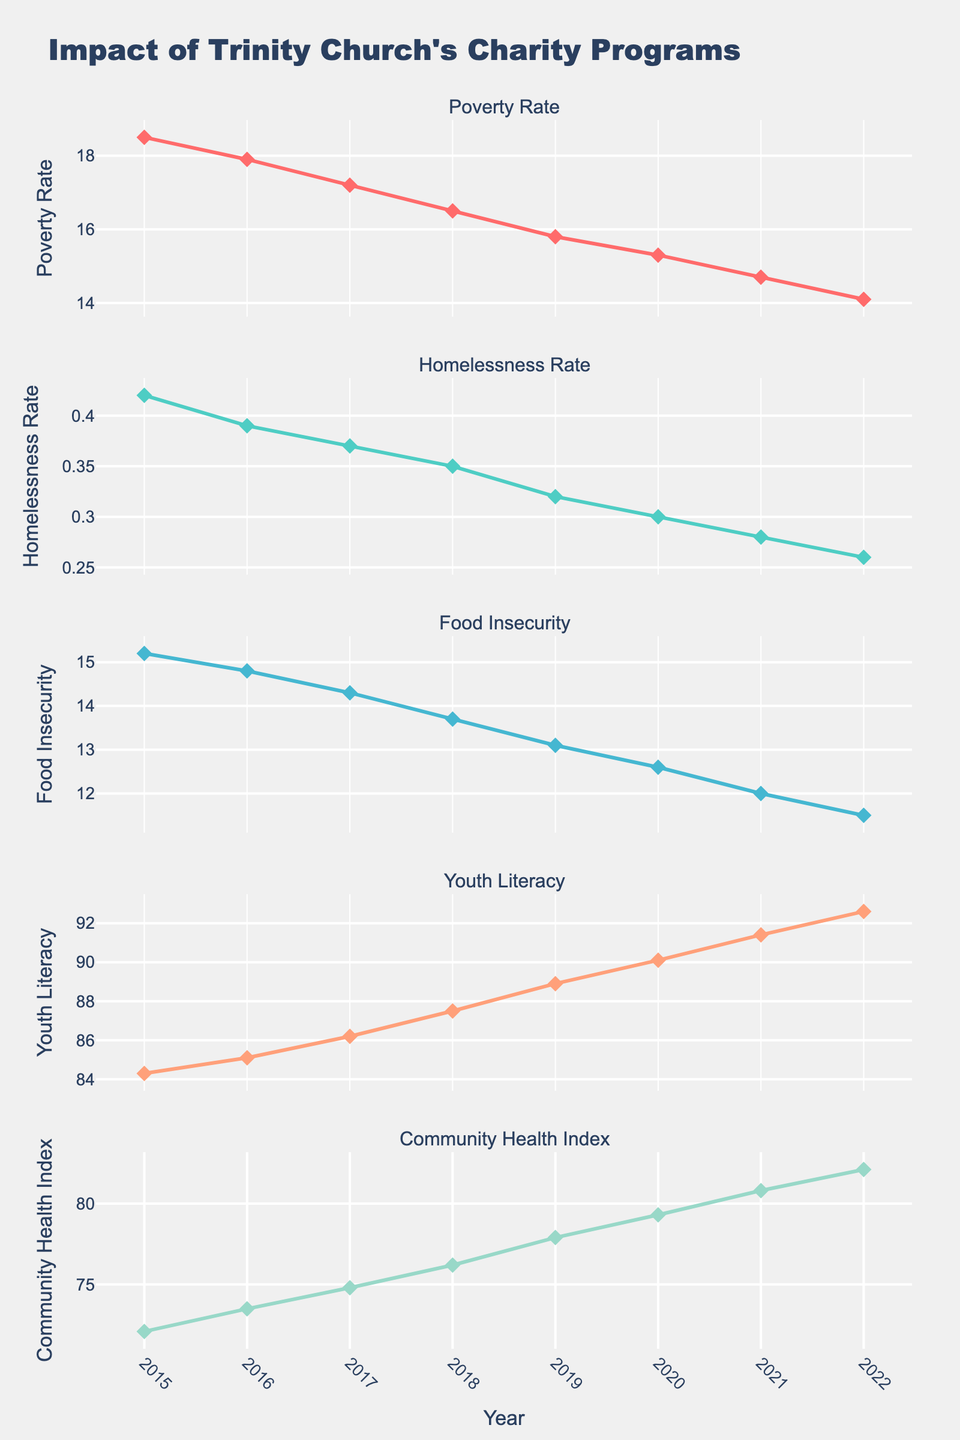What is the overall title of the figure? The title of the figure is located at the top of the chart and usually represents the main idea or objective of the visual.
Answer: Impact of Trinity Church's Charity Programs How many subplots are presented in the figure? By visually counting the distinct sections or panels stacked vertically, we can determine the number of subplots.
Answer: 5 Which metric shows the greatest improvement between 2015 and 2022? To determine the metric with the greatest improvement, look at the vertical difference between the 2015 and 2022 points on each subplot.
Answer: Youth Literacy What is the general trend of the Poverty Rate from 2015 to 2022? Observing the line graph in the Poverty Rate subplot, notice if the line goes up, down, or stays stable over the years.
Answer: Decreasing During which year did the Community Health Index have the highest value? Find the point on the Community Health Index subplot that is highest on the y-axis, and check its corresponding year on the x-axis.
Answer: 2022 By how much did the Homelessness Rate decrease from 2015 to 2022? Subtract the Homelessness Rate value in 2022 from the value in 2015, which are both indicated by their y-axis positions.
Answer: 0.16 What is the relationship between Food Insecurity and Youth Literacy over the years? Compare the trend lines of Food Insecurity and Youth Literacy; see how one changes as the other changes across years.
Answer: Food Insecurity decreases while Youth Literacy increases In which year do Youth Literacy and the Community Health Index both show significant improvements? Look for years where there's a noticeable rise in the values for both Youth Literacy and Community Health Index subplots.
Answer: 2019 What are the colors used for the Poverty Rate and Food Insecurity metrics? By observing the color legends tied to each subplot, identify the specific colors used for these metrics.
Answer: Red for Poverty Rate, Blueish for Food Insecurity Which year had the highest Food Insecurity rate according to the plot? Identify the peak point on the Food Insecurity subplot, noting its highest y-axis value and the corresponding year on the x-axis.
Answer: 2015 